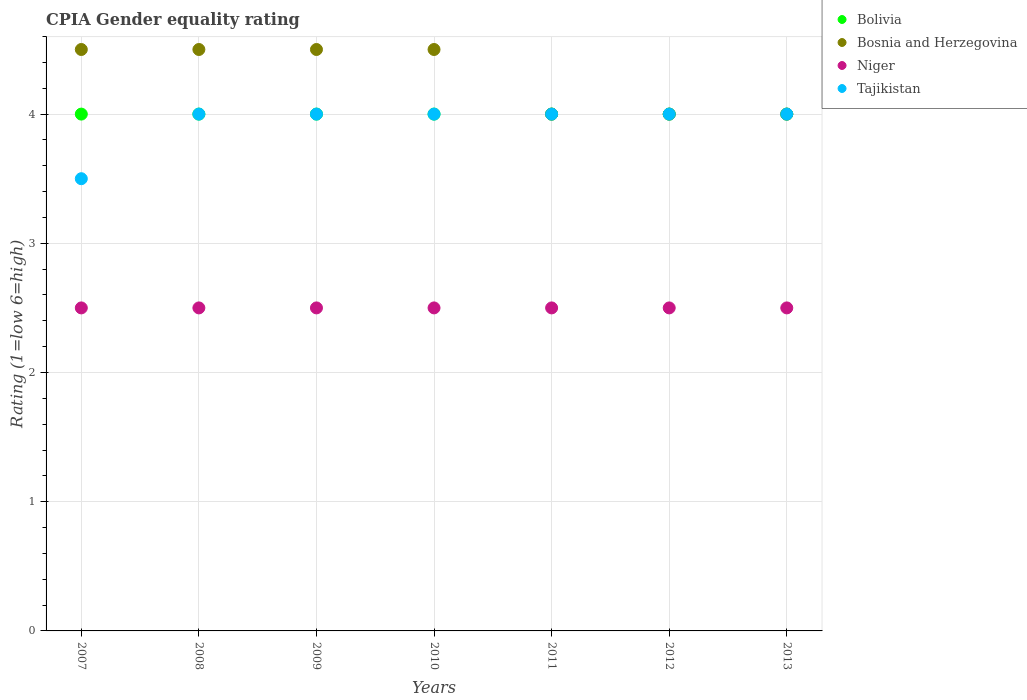How many different coloured dotlines are there?
Provide a short and direct response. 4. Is the number of dotlines equal to the number of legend labels?
Offer a very short reply. Yes. What is the total CPIA rating in Tajikistan in the graph?
Give a very brief answer. 27.5. What is the difference between the CPIA rating in Bosnia and Herzegovina in 2011 and the CPIA rating in Bolivia in 2008?
Keep it short and to the point. 0. What is the average CPIA rating in Bosnia and Herzegovina per year?
Your answer should be compact. 4.29. In the year 2010, what is the difference between the CPIA rating in Niger and CPIA rating in Bosnia and Herzegovina?
Your response must be concise. -2. In how many years, is the CPIA rating in Bolivia greater than 3.4?
Give a very brief answer. 7. Is the CPIA rating in Bosnia and Herzegovina in 2009 less than that in 2012?
Your response must be concise. No. Is the difference between the CPIA rating in Niger in 2008 and 2009 greater than the difference between the CPIA rating in Bosnia and Herzegovina in 2008 and 2009?
Provide a short and direct response. No. What is the difference between the highest and the second highest CPIA rating in Bolivia?
Keep it short and to the point. 0. Is the sum of the CPIA rating in Niger in 2010 and 2011 greater than the maximum CPIA rating in Tajikistan across all years?
Keep it short and to the point. Yes. Is it the case that in every year, the sum of the CPIA rating in Bosnia and Herzegovina and CPIA rating in Tajikistan  is greater than the sum of CPIA rating in Niger and CPIA rating in Bolivia?
Provide a succinct answer. No. Is the CPIA rating in Tajikistan strictly greater than the CPIA rating in Niger over the years?
Your response must be concise. Yes. Is the CPIA rating in Tajikistan strictly less than the CPIA rating in Bosnia and Herzegovina over the years?
Your answer should be very brief. No. How many dotlines are there?
Offer a terse response. 4. How many years are there in the graph?
Give a very brief answer. 7. What is the difference between two consecutive major ticks on the Y-axis?
Your answer should be very brief. 1. Are the values on the major ticks of Y-axis written in scientific E-notation?
Your answer should be very brief. No. Does the graph contain any zero values?
Provide a short and direct response. No. Where does the legend appear in the graph?
Ensure brevity in your answer.  Top right. What is the title of the graph?
Provide a short and direct response. CPIA Gender equality rating. What is the label or title of the Y-axis?
Your answer should be very brief. Rating (1=low 6=high). What is the Rating (1=low 6=high) in Tajikistan in 2007?
Ensure brevity in your answer.  3.5. What is the Rating (1=low 6=high) in Bosnia and Herzegovina in 2008?
Your answer should be compact. 4.5. What is the Rating (1=low 6=high) of Niger in 2008?
Keep it short and to the point. 2.5. What is the Rating (1=low 6=high) of Tajikistan in 2008?
Provide a succinct answer. 4. What is the Rating (1=low 6=high) of Bolivia in 2009?
Provide a succinct answer. 4. What is the Rating (1=low 6=high) of Niger in 2009?
Your answer should be very brief. 2.5. What is the Rating (1=low 6=high) of Bolivia in 2010?
Give a very brief answer. 4. What is the Rating (1=low 6=high) in Tajikistan in 2010?
Your answer should be very brief. 4. What is the Rating (1=low 6=high) of Tajikistan in 2011?
Your answer should be very brief. 4. What is the Rating (1=low 6=high) of Bolivia in 2012?
Your answer should be compact. 4. What is the Rating (1=low 6=high) in Bolivia in 2013?
Give a very brief answer. 4. What is the Rating (1=low 6=high) in Bosnia and Herzegovina in 2013?
Ensure brevity in your answer.  4. What is the Rating (1=low 6=high) of Niger in 2013?
Your answer should be very brief. 2.5. What is the Rating (1=low 6=high) in Tajikistan in 2013?
Make the answer very short. 4. Across all years, what is the maximum Rating (1=low 6=high) of Bolivia?
Your answer should be compact. 4. Across all years, what is the maximum Rating (1=low 6=high) of Niger?
Your answer should be compact. 2.5. Across all years, what is the minimum Rating (1=low 6=high) in Niger?
Offer a terse response. 2.5. What is the total Rating (1=low 6=high) in Tajikistan in the graph?
Make the answer very short. 27.5. What is the difference between the Rating (1=low 6=high) in Bolivia in 2007 and that in 2009?
Provide a succinct answer. 0. What is the difference between the Rating (1=low 6=high) of Niger in 2007 and that in 2011?
Your response must be concise. 0. What is the difference between the Rating (1=low 6=high) in Tajikistan in 2007 and that in 2011?
Your answer should be compact. -0.5. What is the difference between the Rating (1=low 6=high) of Niger in 2007 and that in 2012?
Give a very brief answer. 0. What is the difference between the Rating (1=low 6=high) in Bosnia and Herzegovina in 2007 and that in 2013?
Offer a terse response. 0.5. What is the difference between the Rating (1=low 6=high) of Niger in 2008 and that in 2009?
Your answer should be compact. 0. What is the difference between the Rating (1=low 6=high) of Bolivia in 2008 and that in 2010?
Provide a succinct answer. 0. What is the difference between the Rating (1=low 6=high) of Bosnia and Herzegovina in 2008 and that in 2010?
Make the answer very short. 0. What is the difference between the Rating (1=low 6=high) of Niger in 2008 and that in 2010?
Provide a short and direct response. 0. What is the difference between the Rating (1=low 6=high) of Bolivia in 2008 and that in 2011?
Your answer should be compact. 0. What is the difference between the Rating (1=low 6=high) of Bosnia and Herzegovina in 2008 and that in 2011?
Provide a short and direct response. 0.5. What is the difference between the Rating (1=low 6=high) of Niger in 2008 and that in 2011?
Ensure brevity in your answer.  0. What is the difference between the Rating (1=low 6=high) of Tajikistan in 2008 and that in 2011?
Ensure brevity in your answer.  0. What is the difference between the Rating (1=low 6=high) in Niger in 2008 and that in 2012?
Offer a very short reply. 0. What is the difference between the Rating (1=low 6=high) of Tajikistan in 2008 and that in 2012?
Your response must be concise. 0. What is the difference between the Rating (1=low 6=high) of Bosnia and Herzegovina in 2008 and that in 2013?
Ensure brevity in your answer.  0.5. What is the difference between the Rating (1=low 6=high) in Bolivia in 2009 and that in 2010?
Offer a very short reply. 0. What is the difference between the Rating (1=low 6=high) of Bosnia and Herzegovina in 2009 and that in 2010?
Your answer should be very brief. 0. What is the difference between the Rating (1=low 6=high) of Niger in 2009 and that in 2010?
Your response must be concise. 0. What is the difference between the Rating (1=low 6=high) in Tajikistan in 2009 and that in 2010?
Make the answer very short. 0. What is the difference between the Rating (1=low 6=high) in Bolivia in 2009 and that in 2011?
Offer a very short reply. 0. What is the difference between the Rating (1=low 6=high) in Bolivia in 2009 and that in 2012?
Offer a terse response. 0. What is the difference between the Rating (1=low 6=high) in Bosnia and Herzegovina in 2009 and that in 2012?
Give a very brief answer. 0.5. What is the difference between the Rating (1=low 6=high) of Tajikistan in 2009 and that in 2012?
Ensure brevity in your answer.  0. What is the difference between the Rating (1=low 6=high) of Bolivia in 2009 and that in 2013?
Your answer should be compact. 0. What is the difference between the Rating (1=low 6=high) of Bosnia and Herzegovina in 2009 and that in 2013?
Your answer should be very brief. 0.5. What is the difference between the Rating (1=low 6=high) in Niger in 2009 and that in 2013?
Offer a terse response. 0. What is the difference between the Rating (1=low 6=high) of Tajikistan in 2009 and that in 2013?
Make the answer very short. 0. What is the difference between the Rating (1=low 6=high) in Bolivia in 2010 and that in 2011?
Offer a terse response. 0. What is the difference between the Rating (1=low 6=high) of Bosnia and Herzegovina in 2010 and that in 2011?
Provide a succinct answer. 0.5. What is the difference between the Rating (1=low 6=high) in Niger in 2010 and that in 2011?
Provide a succinct answer. 0. What is the difference between the Rating (1=low 6=high) of Bosnia and Herzegovina in 2010 and that in 2012?
Provide a succinct answer. 0.5. What is the difference between the Rating (1=low 6=high) in Tajikistan in 2010 and that in 2012?
Offer a terse response. 0. What is the difference between the Rating (1=low 6=high) of Bolivia in 2010 and that in 2013?
Offer a very short reply. 0. What is the difference between the Rating (1=low 6=high) of Tajikistan in 2010 and that in 2013?
Your answer should be compact. 0. What is the difference between the Rating (1=low 6=high) of Niger in 2011 and that in 2012?
Your answer should be very brief. 0. What is the difference between the Rating (1=low 6=high) in Bosnia and Herzegovina in 2011 and that in 2013?
Your answer should be compact. 0. What is the difference between the Rating (1=low 6=high) of Bolivia in 2012 and that in 2013?
Ensure brevity in your answer.  0. What is the difference between the Rating (1=low 6=high) in Bosnia and Herzegovina in 2012 and that in 2013?
Keep it short and to the point. 0. What is the difference between the Rating (1=low 6=high) of Niger in 2012 and that in 2013?
Ensure brevity in your answer.  0. What is the difference between the Rating (1=low 6=high) in Bolivia in 2007 and the Rating (1=low 6=high) in Niger in 2008?
Offer a very short reply. 1.5. What is the difference between the Rating (1=low 6=high) of Bolivia in 2007 and the Rating (1=low 6=high) of Tajikistan in 2008?
Your answer should be compact. 0. What is the difference between the Rating (1=low 6=high) of Bolivia in 2007 and the Rating (1=low 6=high) of Niger in 2009?
Give a very brief answer. 1.5. What is the difference between the Rating (1=low 6=high) in Bolivia in 2007 and the Rating (1=low 6=high) in Tajikistan in 2009?
Make the answer very short. 0. What is the difference between the Rating (1=low 6=high) of Bosnia and Herzegovina in 2007 and the Rating (1=low 6=high) of Niger in 2009?
Make the answer very short. 2. What is the difference between the Rating (1=low 6=high) in Niger in 2007 and the Rating (1=low 6=high) in Tajikistan in 2009?
Provide a succinct answer. -1.5. What is the difference between the Rating (1=low 6=high) in Bolivia in 2007 and the Rating (1=low 6=high) in Tajikistan in 2010?
Give a very brief answer. 0. What is the difference between the Rating (1=low 6=high) in Niger in 2007 and the Rating (1=low 6=high) in Tajikistan in 2010?
Your answer should be compact. -1.5. What is the difference between the Rating (1=low 6=high) in Bolivia in 2007 and the Rating (1=low 6=high) in Tajikistan in 2011?
Offer a very short reply. 0. What is the difference between the Rating (1=low 6=high) of Bosnia and Herzegovina in 2007 and the Rating (1=low 6=high) of Niger in 2011?
Your answer should be compact. 2. What is the difference between the Rating (1=low 6=high) in Niger in 2007 and the Rating (1=low 6=high) in Tajikistan in 2011?
Offer a very short reply. -1.5. What is the difference between the Rating (1=low 6=high) in Bolivia in 2007 and the Rating (1=low 6=high) in Niger in 2013?
Provide a short and direct response. 1.5. What is the difference between the Rating (1=low 6=high) in Bolivia in 2007 and the Rating (1=low 6=high) in Tajikistan in 2013?
Offer a very short reply. 0. What is the difference between the Rating (1=low 6=high) in Bosnia and Herzegovina in 2007 and the Rating (1=low 6=high) in Niger in 2013?
Your answer should be compact. 2. What is the difference between the Rating (1=low 6=high) in Niger in 2007 and the Rating (1=low 6=high) in Tajikistan in 2013?
Your answer should be compact. -1.5. What is the difference between the Rating (1=low 6=high) in Bosnia and Herzegovina in 2008 and the Rating (1=low 6=high) in Niger in 2009?
Ensure brevity in your answer.  2. What is the difference between the Rating (1=low 6=high) of Bolivia in 2008 and the Rating (1=low 6=high) of Bosnia and Herzegovina in 2010?
Provide a short and direct response. -0.5. What is the difference between the Rating (1=low 6=high) of Bosnia and Herzegovina in 2008 and the Rating (1=low 6=high) of Tajikistan in 2010?
Give a very brief answer. 0.5. What is the difference between the Rating (1=low 6=high) in Bolivia in 2008 and the Rating (1=low 6=high) in Niger in 2011?
Offer a very short reply. 1.5. What is the difference between the Rating (1=low 6=high) in Bolivia in 2008 and the Rating (1=low 6=high) in Tajikistan in 2011?
Give a very brief answer. 0. What is the difference between the Rating (1=low 6=high) in Bolivia in 2008 and the Rating (1=low 6=high) in Niger in 2012?
Provide a short and direct response. 1.5. What is the difference between the Rating (1=low 6=high) of Bosnia and Herzegovina in 2008 and the Rating (1=low 6=high) of Niger in 2012?
Your answer should be very brief. 2. What is the difference between the Rating (1=low 6=high) of Niger in 2008 and the Rating (1=low 6=high) of Tajikistan in 2012?
Keep it short and to the point. -1.5. What is the difference between the Rating (1=low 6=high) in Bolivia in 2008 and the Rating (1=low 6=high) in Niger in 2013?
Offer a terse response. 1.5. What is the difference between the Rating (1=low 6=high) in Niger in 2008 and the Rating (1=low 6=high) in Tajikistan in 2013?
Offer a very short reply. -1.5. What is the difference between the Rating (1=low 6=high) of Bolivia in 2009 and the Rating (1=low 6=high) of Niger in 2010?
Ensure brevity in your answer.  1.5. What is the difference between the Rating (1=low 6=high) in Bosnia and Herzegovina in 2009 and the Rating (1=low 6=high) in Niger in 2010?
Your response must be concise. 2. What is the difference between the Rating (1=low 6=high) of Bolivia in 2009 and the Rating (1=low 6=high) of Bosnia and Herzegovina in 2011?
Your response must be concise. 0. What is the difference between the Rating (1=low 6=high) of Bolivia in 2009 and the Rating (1=low 6=high) of Tajikistan in 2011?
Your response must be concise. 0. What is the difference between the Rating (1=low 6=high) of Bosnia and Herzegovina in 2009 and the Rating (1=low 6=high) of Niger in 2011?
Your answer should be compact. 2. What is the difference between the Rating (1=low 6=high) in Bolivia in 2009 and the Rating (1=low 6=high) in Bosnia and Herzegovina in 2012?
Provide a succinct answer. 0. What is the difference between the Rating (1=low 6=high) in Bolivia in 2009 and the Rating (1=low 6=high) in Niger in 2012?
Offer a very short reply. 1.5. What is the difference between the Rating (1=low 6=high) in Bolivia in 2009 and the Rating (1=low 6=high) in Tajikistan in 2012?
Your answer should be very brief. 0. What is the difference between the Rating (1=low 6=high) in Bosnia and Herzegovina in 2009 and the Rating (1=low 6=high) in Niger in 2012?
Give a very brief answer. 2. What is the difference between the Rating (1=low 6=high) of Bosnia and Herzegovina in 2009 and the Rating (1=low 6=high) of Tajikistan in 2012?
Your response must be concise. 0.5. What is the difference between the Rating (1=low 6=high) in Niger in 2009 and the Rating (1=low 6=high) in Tajikistan in 2012?
Give a very brief answer. -1.5. What is the difference between the Rating (1=low 6=high) of Bolivia in 2009 and the Rating (1=low 6=high) of Tajikistan in 2013?
Make the answer very short. 0. What is the difference between the Rating (1=low 6=high) of Bosnia and Herzegovina in 2009 and the Rating (1=low 6=high) of Tajikistan in 2013?
Your answer should be compact. 0.5. What is the difference between the Rating (1=low 6=high) in Niger in 2009 and the Rating (1=low 6=high) in Tajikistan in 2013?
Keep it short and to the point. -1.5. What is the difference between the Rating (1=low 6=high) of Bolivia in 2010 and the Rating (1=low 6=high) of Niger in 2011?
Offer a very short reply. 1.5. What is the difference between the Rating (1=low 6=high) in Bosnia and Herzegovina in 2010 and the Rating (1=low 6=high) in Tajikistan in 2011?
Your answer should be compact. 0.5. What is the difference between the Rating (1=low 6=high) of Bolivia in 2010 and the Rating (1=low 6=high) of Bosnia and Herzegovina in 2012?
Provide a succinct answer. 0. What is the difference between the Rating (1=low 6=high) in Bolivia in 2010 and the Rating (1=low 6=high) in Bosnia and Herzegovina in 2013?
Your answer should be compact. 0. What is the difference between the Rating (1=low 6=high) in Bolivia in 2010 and the Rating (1=low 6=high) in Niger in 2013?
Your answer should be compact. 1.5. What is the difference between the Rating (1=low 6=high) in Bolivia in 2010 and the Rating (1=low 6=high) in Tajikistan in 2013?
Make the answer very short. 0. What is the difference between the Rating (1=low 6=high) of Bolivia in 2011 and the Rating (1=low 6=high) of Bosnia and Herzegovina in 2012?
Offer a terse response. 0. What is the difference between the Rating (1=low 6=high) in Bolivia in 2011 and the Rating (1=low 6=high) in Niger in 2012?
Your answer should be compact. 1.5. What is the difference between the Rating (1=low 6=high) in Bolivia in 2011 and the Rating (1=low 6=high) in Tajikistan in 2012?
Provide a succinct answer. 0. What is the difference between the Rating (1=low 6=high) in Niger in 2011 and the Rating (1=low 6=high) in Tajikistan in 2012?
Your answer should be compact. -1.5. What is the difference between the Rating (1=low 6=high) in Bolivia in 2011 and the Rating (1=low 6=high) in Bosnia and Herzegovina in 2013?
Your answer should be compact. 0. What is the difference between the Rating (1=low 6=high) in Bolivia in 2011 and the Rating (1=low 6=high) in Tajikistan in 2013?
Offer a very short reply. 0. What is the difference between the Rating (1=low 6=high) of Bosnia and Herzegovina in 2011 and the Rating (1=low 6=high) of Tajikistan in 2013?
Your answer should be very brief. 0. What is the difference between the Rating (1=low 6=high) of Bolivia in 2012 and the Rating (1=low 6=high) of Niger in 2013?
Make the answer very short. 1.5. What is the difference between the Rating (1=low 6=high) of Bosnia and Herzegovina in 2012 and the Rating (1=low 6=high) of Tajikistan in 2013?
Offer a terse response. 0. What is the difference between the Rating (1=low 6=high) in Niger in 2012 and the Rating (1=low 6=high) in Tajikistan in 2013?
Make the answer very short. -1.5. What is the average Rating (1=low 6=high) in Bolivia per year?
Make the answer very short. 4. What is the average Rating (1=low 6=high) of Bosnia and Herzegovina per year?
Provide a succinct answer. 4.29. What is the average Rating (1=low 6=high) in Niger per year?
Ensure brevity in your answer.  2.5. What is the average Rating (1=low 6=high) of Tajikistan per year?
Keep it short and to the point. 3.93. In the year 2007, what is the difference between the Rating (1=low 6=high) of Bosnia and Herzegovina and Rating (1=low 6=high) of Tajikistan?
Offer a terse response. 1. In the year 2008, what is the difference between the Rating (1=low 6=high) in Bolivia and Rating (1=low 6=high) in Bosnia and Herzegovina?
Offer a terse response. -0.5. In the year 2008, what is the difference between the Rating (1=low 6=high) in Bolivia and Rating (1=low 6=high) in Niger?
Your response must be concise. 1.5. In the year 2008, what is the difference between the Rating (1=low 6=high) of Bolivia and Rating (1=low 6=high) of Tajikistan?
Ensure brevity in your answer.  0. In the year 2009, what is the difference between the Rating (1=low 6=high) of Bolivia and Rating (1=low 6=high) of Bosnia and Herzegovina?
Your answer should be very brief. -0.5. In the year 2009, what is the difference between the Rating (1=low 6=high) in Bolivia and Rating (1=low 6=high) in Niger?
Your answer should be very brief. 1.5. In the year 2009, what is the difference between the Rating (1=low 6=high) of Bosnia and Herzegovina and Rating (1=low 6=high) of Niger?
Your answer should be compact. 2. In the year 2009, what is the difference between the Rating (1=low 6=high) in Bosnia and Herzegovina and Rating (1=low 6=high) in Tajikistan?
Your answer should be compact. 0.5. In the year 2009, what is the difference between the Rating (1=low 6=high) in Niger and Rating (1=low 6=high) in Tajikistan?
Make the answer very short. -1.5. In the year 2010, what is the difference between the Rating (1=low 6=high) in Bolivia and Rating (1=low 6=high) in Bosnia and Herzegovina?
Make the answer very short. -0.5. In the year 2010, what is the difference between the Rating (1=low 6=high) in Bolivia and Rating (1=low 6=high) in Niger?
Provide a succinct answer. 1.5. In the year 2010, what is the difference between the Rating (1=low 6=high) of Bosnia and Herzegovina and Rating (1=low 6=high) of Niger?
Your answer should be compact. 2. In the year 2010, what is the difference between the Rating (1=low 6=high) of Bosnia and Herzegovina and Rating (1=low 6=high) of Tajikistan?
Your answer should be compact. 0.5. In the year 2010, what is the difference between the Rating (1=low 6=high) of Niger and Rating (1=low 6=high) of Tajikistan?
Ensure brevity in your answer.  -1.5. In the year 2011, what is the difference between the Rating (1=low 6=high) in Bosnia and Herzegovina and Rating (1=low 6=high) in Niger?
Provide a short and direct response. 1.5. In the year 2011, what is the difference between the Rating (1=low 6=high) of Bosnia and Herzegovina and Rating (1=low 6=high) of Tajikistan?
Your answer should be compact. 0. In the year 2011, what is the difference between the Rating (1=low 6=high) in Niger and Rating (1=low 6=high) in Tajikistan?
Provide a succinct answer. -1.5. In the year 2012, what is the difference between the Rating (1=low 6=high) of Bolivia and Rating (1=low 6=high) of Bosnia and Herzegovina?
Your answer should be compact. 0. In the year 2012, what is the difference between the Rating (1=low 6=high) of Bolivia and Rating (1=low 6=high) of Tajikistan?
Offer a very short reply. 0. In the year 2012, what is the difference between the Rating (1=low 6=high) in Bosnia and Herzegovina and Rating (1=low 6=high) in Niger?
Your answer should be very brief. 1.5. In the year 2013, what is the difference between the Rating (1=low 6=high) in Bolivia and Rating (1=low 6=high) in Tajikistan?
Your answer should be compact. 0. In the year 2013, what is the difference between the Rating (1=low 6=high) in Bosnia and Herzegovina and Rating (1=low 6=high) in Tajikistan?
Make the answer very short. 0. In the year 2013, what is the difference between the Rating (1=low 6=high) of Niger and Rating (1=low 6=high) of Tajikistan?
Provide a succinct answer. -1.5. What is the ratio of the Rating (1=low 6=high) in Bolivia in 2007 to that in 2008?
Ensure brevity in your answer.  1. What is the ratio of the Rating (1=low 6=high) of Bosnia and Herzegovina in 2007 to that in 2008?
Give a very brief answer. 1. What is the ratio of the Rating (1=low 6=high) in Niger in 2007 to that in 2008?
Offer a very short reply. 1. What is the ratio of the Rating (1=low 6=high) in Bolivia in 2007 to that in 2009?
Ensure brevity in your answer.  1. What is the ratio of the Rating (1=low 6=high) of Tajikistan in 2007 to that in 2009?
Your response must be concise. 0.88. What is the ratio of the Rating (1=low 6=high) in Bosnia and Herzegovina in 2007 to that in 2010?
Give a very brief answer. 1. What is the ratio of the Rating (1=low 6=high) in Tajikistan in 2007 to that in 2010?
Offer a terse response. 0.88. What is the ratio of the Rating (1=low 6=high) of Bolivia in 2007 to that in 2011?
Provide a succinct answer. 1. What is the ratio of the Rating (1=low 6=high) of Niger in 2007 to that in 2011?
Provide a short and direct response. 1. What is the ratio of the Rating (1=low 6=high) in Bolivia in 2007 to that in 2012?
Give a very brief answer. 1. What is the ratio of the Rating (1=low 6=high) of Bosnia and Herzegovina in 2007 to that in 2012?
Your answer should be very brief. 1.12. What is the ratio of the Rating (1=low 6=high) in Niger in 2007 to that in 2012?
Give a very brief answer. 1. What is the ratio of the Rating (1=low 6=high) of Bolivia in 2008 to that in 2009?
Make the answer very short. 1. What is the ratio of the Rating (1=low 6=high) of Bosnia and Herzegovina in 2008 to that in 2009?
Give a very brief answer. 1. What is the ratio of the Rating (1=low 6=high) of Bolivia in 2008 to that in 2010?
Your response must be concise. 1. What is the ratio of the Rating (1=low 6=high) in Bosnia and Herzegovina in 2008 to that in 2010?
Keep it short and to the point. 1. What is the ratio of the Rating (1=low 6=high) of Bolivia in 2008 to that in 2011?
Your response must be concise. 1. What is the ratio of the Rating (1=low 6=high) of Niger in 2008 to that in 2012?
Your response must be concise. 1. What is the ratio of the Rating (1=low 6=high) in Bosnia and Herzegovina in 2008 to that in 2013?
Provide a succinct answer. 1.12. What is the ratio of the Rating (1=low 6=high) of Niger in 2008 to that in 2013?
Your response must be concise. 1. What is the ratio of the Rating (1=low 6=high) in Tajikistan in 2008 to that in 2013?
Keep it short and to the point. 1. What is the ratio of the Rating (1=low 6=high) in Bosnia and Herzegovina in 2009 to that in 2010?
Make the answer very short. 1. What is the ratio of the Rating (1=low 6=high) in Niger in 2009 to that in 2010?
Your response must be concise. 1. What is the ratio of the Rating (1=low 6=high) in Bolivia in 2009 to that in 2011?
Ensure brevity in your answer.  1. What is the ratio of the Rating (1=low 6=high) of Niger in 2009 to that in 2011?
Offer a terse response. 1. What is the ratio of the Rating (1=low 6=high) in Bosnia and Herzegovina in 2009 to that in 2012?
Make the answer very short. 1.12. What is the ratio of the Rating (1=low 6=high) of Tajikistan in 2009 to that in 2012?
Ensure brevity in your answer.  1. What is the ratio of the Rating (1=low 6=high) of Bosnia and Herzegovina in 2009 to that in 2013?
Provide a short and direct response. 1.12. What is the ratio of the Rating (1=low 6=high) in Niger in 2009 to that in 2013?
Your answer should be compact. 1. What is the ratio of the Rating (1=low 6=high) in Bolivia in 2010 to that in 2011?
Your answer should be compact. 1. What is the ratio of the Rating (1=low 6=high) of Bosnia and Herzegovina in 2010 to that in 2011?
Offer a terse response. 1.12. What is the ratio of the Rating (1=low 6=high) in Tajikistan in 2010 to that in 2011?
Provide a succinct answer. 1. What is the ratio of the Rating (1=low 6=high) in Bosnia and Herzegovina in 2010 to that in 2012?
Make the answer very short. 1.12. What is the ratio of the Rating (1=low 6=high) of Bosnia and Herzegovina in 2010 to that in 2013?
Offer a very short reply. 1.12. What is the ratio of the Rating (1=low 6=high) of Bosnia and Herzegovina in 2011 to that in 2012?
Ensure brevity in your answer.  1. What is the ratio of the Rating (1=low 6=high) of Niger in 2011 to that in 2012?
Keep it short and to the point. 1. What is the ratio of the Rating (1=low 6=high) in Tajikistan in 2011 to that in 2012?
Offer a terse response. 1. What is the ratio of the Rating (1=low 6=high) of Bosnia and Herzegovina in 2011 to that in 2013?
Give a very brief answer. 1. What is the ratio of the Rating (1=low 6=high) in Niger in 2011 to that in 2013?
Your answer should be very brief. 1. What is the ratio of the Rating (1=low 6=high) in Tajikistan in 2012 to that in 2013?
Offer a very short reply. 1. What is the difference between the highest and the second highest Rating (1=low 6=high) in Bolivia?
Offer a very short reply. 0. What is the difference between the highest and the second highest Rating (1=low 6=high) in Niger?
Ensure brevity in your answer.  0. What is the difference between the highest and the lowest Rating (1=low 6=high) in Bosnia and Herzegovina?
Your response must be concise. 0.5. 